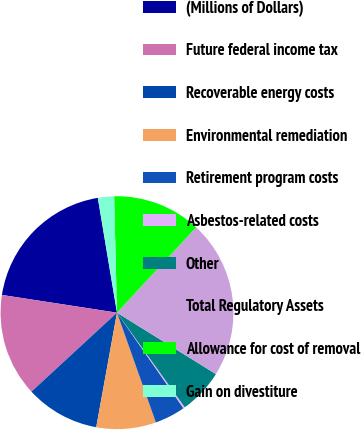<chart> <loc_0><loc_0><loc_500><loc_500><pie_chart><fcel>(Millions of Dollars)<fcel>Future federal income tax<fcel>Recoverable energy costs<fcel>Environmental remediation<fcel>Retirement program costs<fcel>Asbestos-related costs<fcel>Other<fcel>Total Regulatory Assets<fcel>Allowance for cost of removal<fcel>Gain on divestiture<nl><fcel>19.93%<fcel>14.3%<fcel>10.28%<fcel>8.27%<fcel>4.25%<fcel>0.23%<fcel>6.26%<fcel>21.94%<fcel>12.29%<fcel>2.24%<nl></chart> 